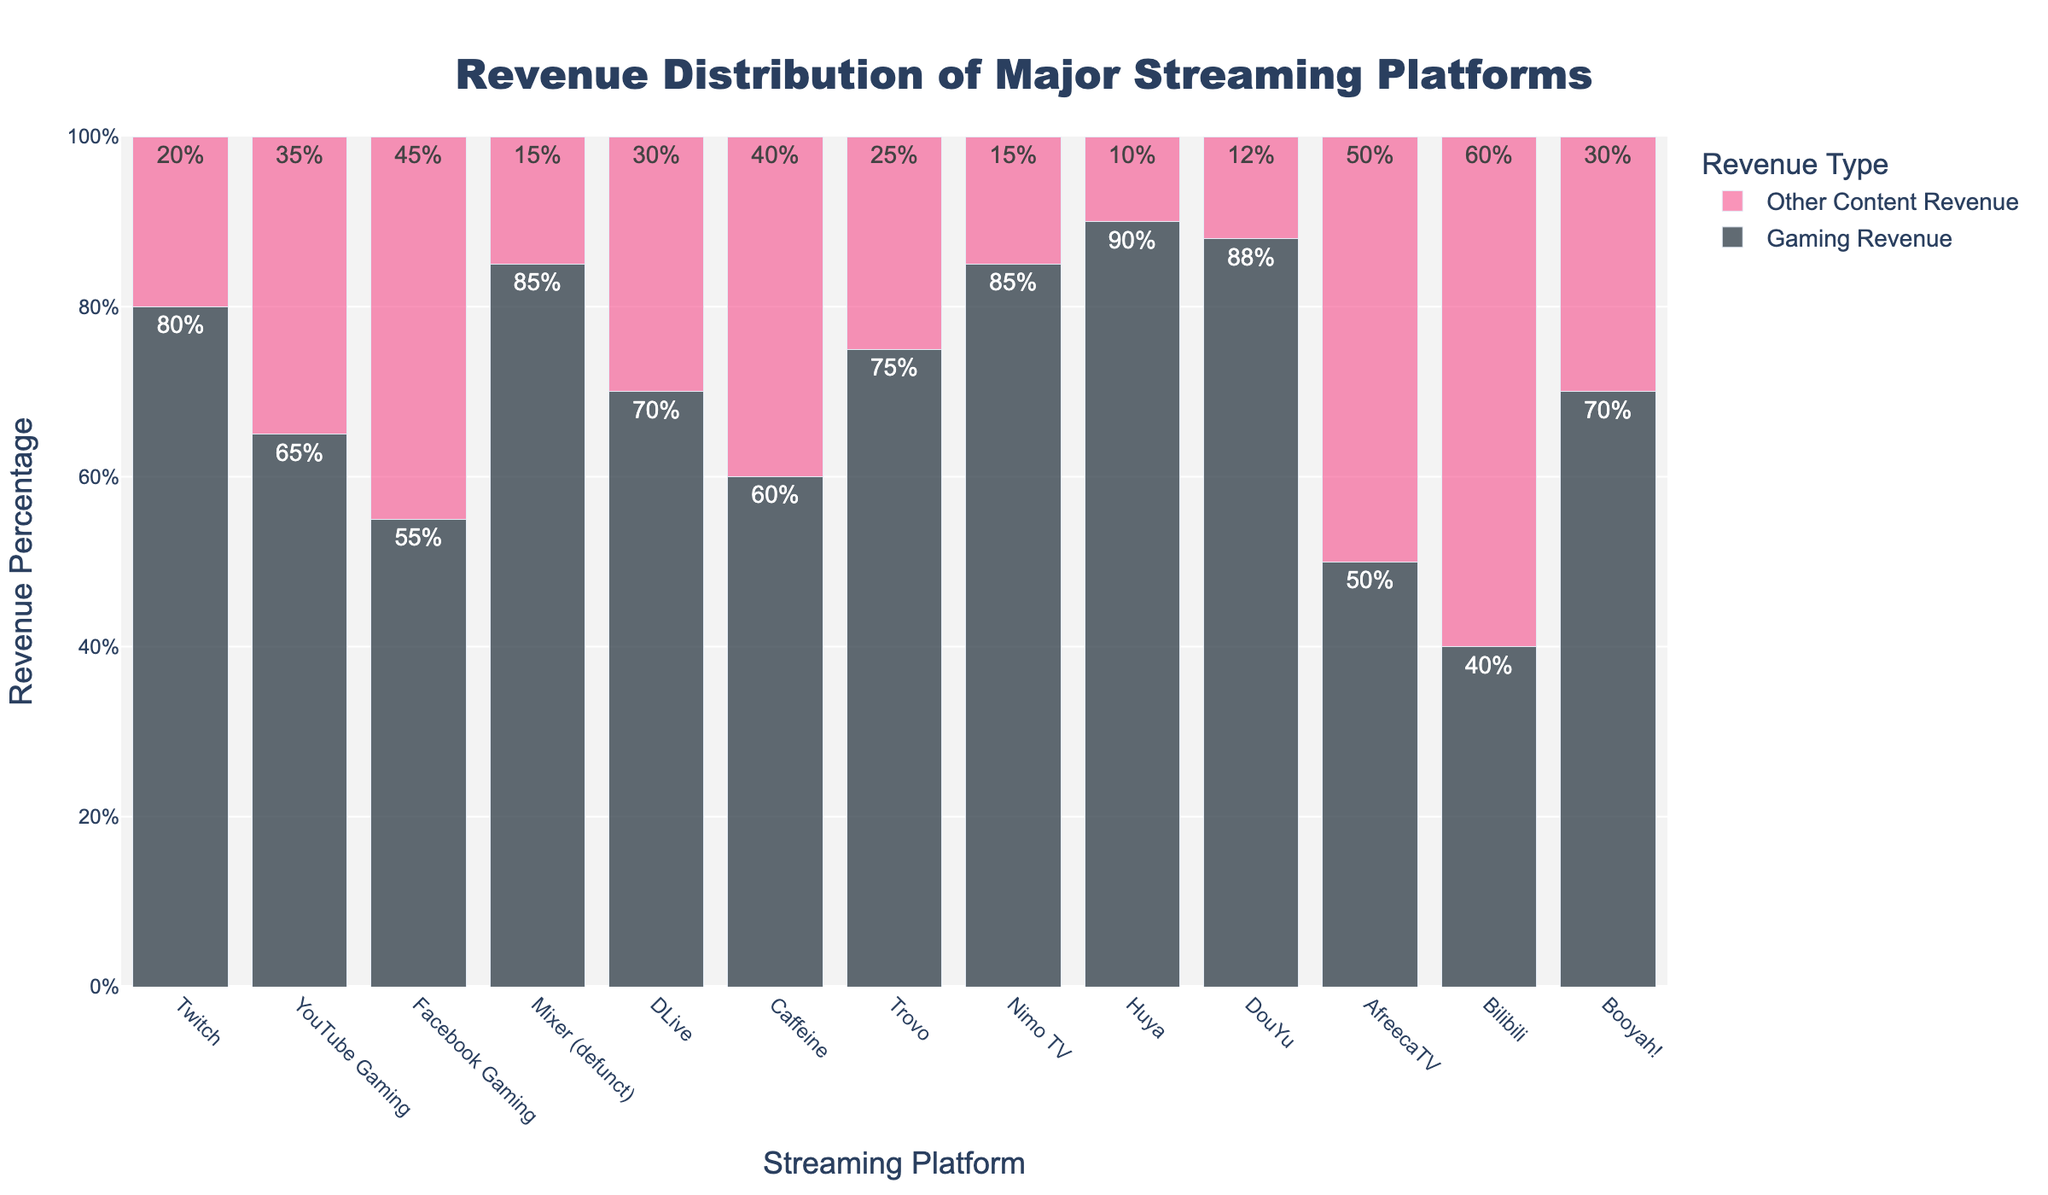Which streaming platform has the highest percentage of revenue from gaming content? Look at the heights of the bars labeled 'Gaming Revenue'. The tallest bar represents the platform with the highest gaming revenue percentage.
Answer: Huya What is the difference in gaming revenue percentages between Twitch and Bilibili? Refer to the 'Gaming Revenue' bars for both Twitch and Bilibili and subtract the latter's percentage from the former's. Twitch has 80%, and Bilibili has 40%. 80% - 40% = 40%.
Answer: 40% Which platform has an equal percentage of revenue from gaming content and other content? Look for the bars where the 'Gaming Revenue' and 'Other Content Revenue' bars are of equal height. AfreecaTV shows 50% for both types of revenue.
Answer: AfreecaTV What is the combined gaming revenue percentage for Facebook Gaming and Trovo? Add the gaming revenue percentages for both Facebook Gaming and Trovo. Facebook Gaming: 55%, Trovo: 75%. 55% + 75% = 130%.
Answer: 130% Which platform has a higher percentage of revenue from other content, YouTube Gaming or Caffeine? Compare the heights of the 'Other Content Revenue' bars for YouTube Gaming and Caffeine. YouTube Gaming has 35%, while Caffeine has 40%.
Answer: Caffeine What is the average gaming revenue percentage across all platforms? Add the gaming revenue percentages for all platforms, and divide by the number of platforms (13). (80 + 65 + 55 + 85 + 70 + 60 + 75 + 85 + 90 + 88 + 50 + 40 + 70) / 13 = 69%.
Answer: 69% Which platform has the widest gap between gaming revenue and other content revenue? Subtract each platform's 'Other Content Revenue' percentage from its 'Gaming Revenue' percentage. The largest difference indicates the widest gap. Huya has Gaming: 90% and Other: 10%, which is a gap of 80%.
Answer: Huya How does the percentage of gaming revenue for Mixer compare to that of DouYu? Compare the heights of the 'Gaming Revenue' bars for Mixer and DouYu. Mixer has 85% gaming revenue, and DouYu has 88%. 85% < 88%.
Answer: DouYu is higher Which platform earns more from other content, Nimo TV or Booyah!? Compare the heights of the 'Other Content Revenue' bars for Nimo TV and Booyah!. Nimo TV has 15%, and Booyah! has 30%.
Answer: Booyah! 